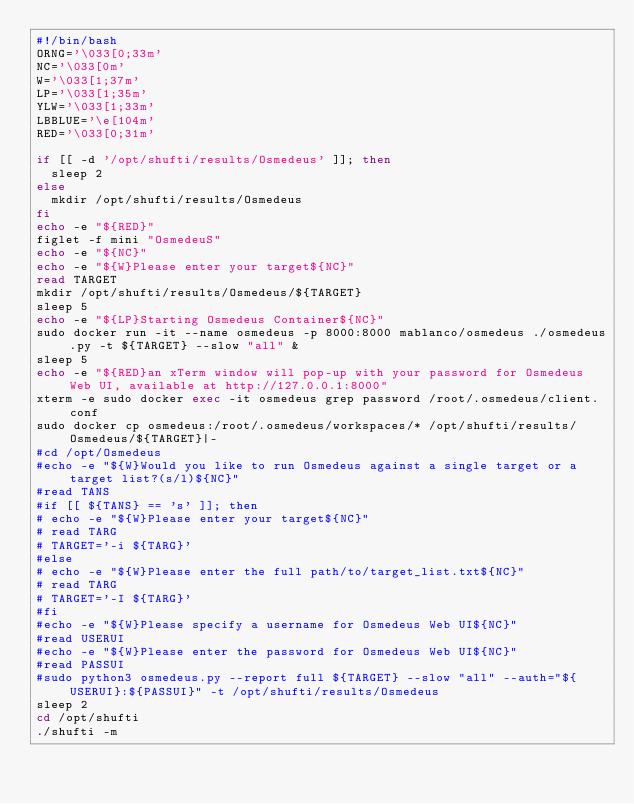<code> <loc_0><loc_0><loc_500><loc_500><_Bash_>#!/bin/bash
ORNG='\033[0;33m'
NC='\033[0m'
W='\033[1;37m'
LP='\033[1;35m'
YLW='\033[1;33m'
LBBLUE='\e[104m'
RED='\033[0;31m'

if [[ -d '/opt/shufti/results/Osmedeus' ]]; then
	sleep 2
else
	mkdir /opt/shufti/results/Osmedeus
fi
echo -e "${RED}"
figlet -f mini "OsmedeuS"
echo -e "${NC}"
echo -e "${W}Please enter your target${NC}"
read TARGET
mkdir /opt/shufti/results/Osmedeus/${TARGET}
sleep 5
echo -e "${LP}Starting Osmedeus Container${NC}"
sudo docker run -it --name osmedeus -p 8000:8000 mablanco/osmedeus ./osmedeus.py -t ${TARGET} --slow "all" &
sleep 5
echo -e "${RED}an xTerm window will pop-up with your password for Osmedeus Web UI, available at http://127.0.0.1:8000"
xterm -e sudo docker exec -it osmedeus grep password /root/.osmedeus/client.conf
sudo docker cp osmedeus:/root/.osmedeus/workspaces/* /opt/shufti/results/Osmedeus/${TARGET}|-
#cd /opt/Osmedeus
#echo -e "${W}Would you like to run Osmedeus against a single target or a target list?(s/l)${NC}"
#read TANS
#if [[ ${TANS} == 's' ]]; then
#	echo -e "${W}Please enter your target${NC}"
#	read TARG
#	TARGET='-i ${TARG}'
#else
#	echo -e "${W}Please enter the full path/to/target_list.txt${NC}"
#	read TARG
#	TARGET='-I ${TARG}'
#fi 
#echo -e "${W}Please specify a username for Osmedeus Web UI${NC}"
#read USERUI
#echo -e "${W}Please enter the password for Osmedeus Web UI${NC}"
#read PASSUI
#sudo python3 osmedeus.py --report full ${TARGET} --slow "all" --auth="${USERUI}:${PASSUI}" -t /opt/shufti/results/Osmedeus
sleep 2
cd /opt/shufti
./shufti -m

</code> 